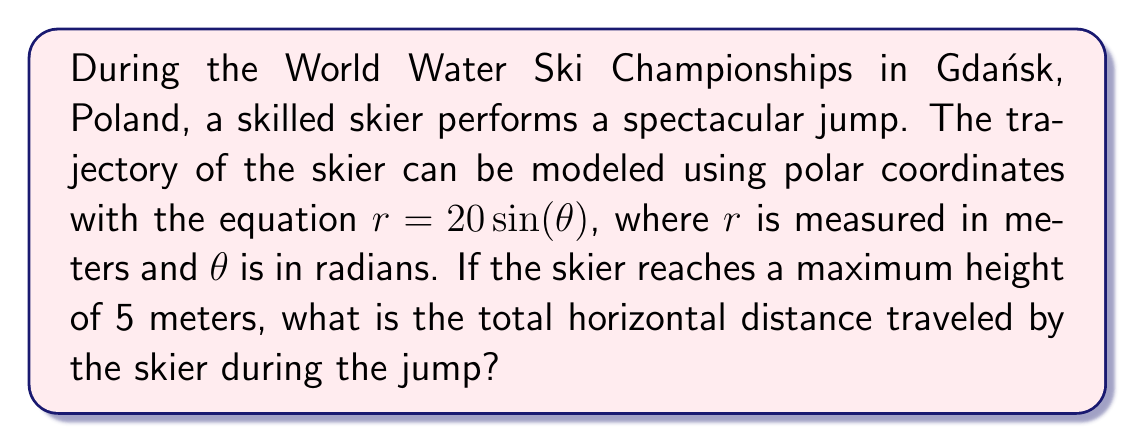Teach me how to tackle this problem. Let's approach this step-by-step:

1) The polar equation $r = 20 \sin(\theta)$ describes a circle with diameter 20 meters. The skier's trajectory is the top half of this circle.

2) To find the maximum height, we need to find the maximum value of $y$ in Cartesian coordinates. In polar coordinates, $y = r \sin(\theta)$:

   $y = 20 \sin(\theta) \sin(\theta) = 10 \sin(2\theta)$

3) The maximum value of $y$ occurs when $\sin(2\theta) = 1$, which is when $2\theta = \frac{\pi}{2}$ or $\theta = \frac{\pi}{4}$.

4) We're told the maximum height is 5 meters. This means:

   $5 = 10 \sin(\frac{\pi}{2}) = 10$

5) To adjust our equation to match the given maximum height, we need to scale it by a factor of $\frac{1}{2}$. Our new equation is:

   $r = 10 \sin(\theta)$

6) To find the horizontal distance, we need to find the $x$-coordinate when $y = 0$ (i.e., at the beginning and end of the jump). In Cartesian coordinates:

   $x = r \cos(\theta) = 10 \sin(\theta) \cos(\theta) = 5 \sin(2\theta)$

7) $y = 0$ when $\theta = 0$ and $\theta = \pi$. At $\theta = \frac{\pi}{2}$, $x$ reaches its maximum value:

   $x_{max} = 5 \sin(\pi) = 5$

8) The total horizontal distance is twice this value:

   $\text{Total distance} = 2 * 5 = 10$ meters

[asy]
import graph;
size(200);
real r(real t) {return 10*sin(t);}
draw(polargraph(r,0,pi),blue);
draw((0,-0.5)--(0,5.5),arrow=Arrow(TeXHead));
draw((-0.5,0)--(5.5,0),arrow=Arrow(TeXHead));
label("$x$",(5.5,0),E);
label("$y$",(0,5.5),N);
dot((5,0));
dot((0,0));
label("5 m",(2.5,0),S);
label("5 m",(0,2.5),W);
[/asy]
Answer: The total horizontal distance traveled by the skier during the jump is 10 meters. 